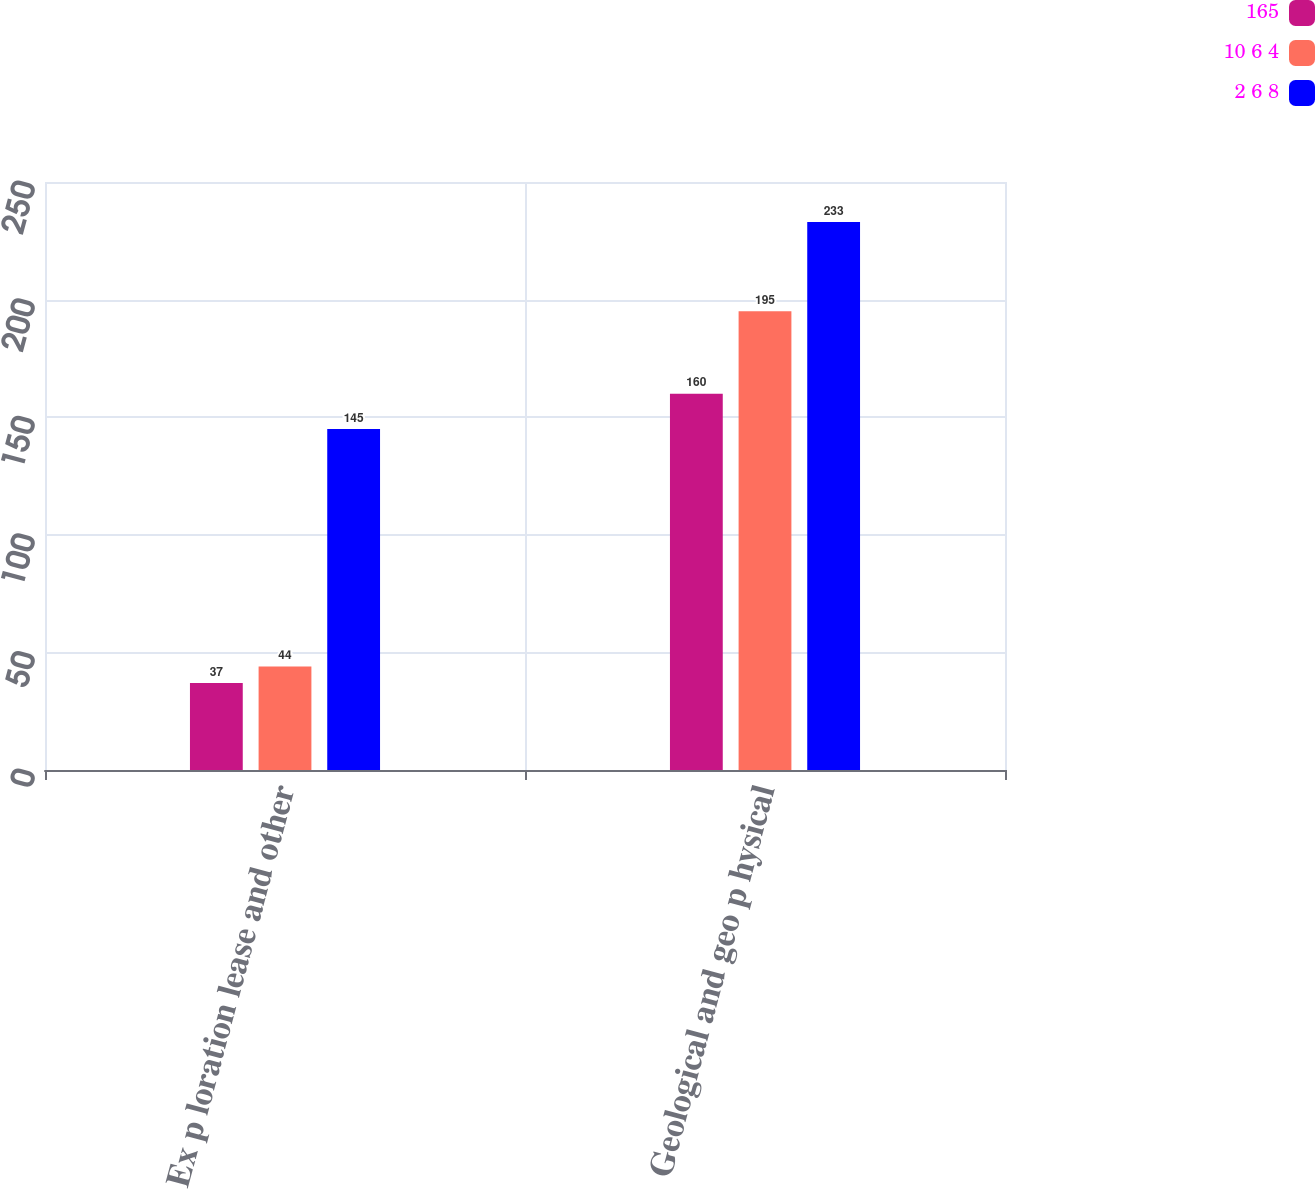<chart> <loc_0><loc_0><loc_500><loc_500><stacked_bar_chart><ecel><fcel>Ex p loration lease and other<fcel>Geological and geo p hysical<nl><fcel>165<fcel>37<fcel>160<nl><fcel>10 6 4<fcel>44<fcel>195<nl><fcel>2 6 8<fcel>145<fcel>233<nl></chart> 